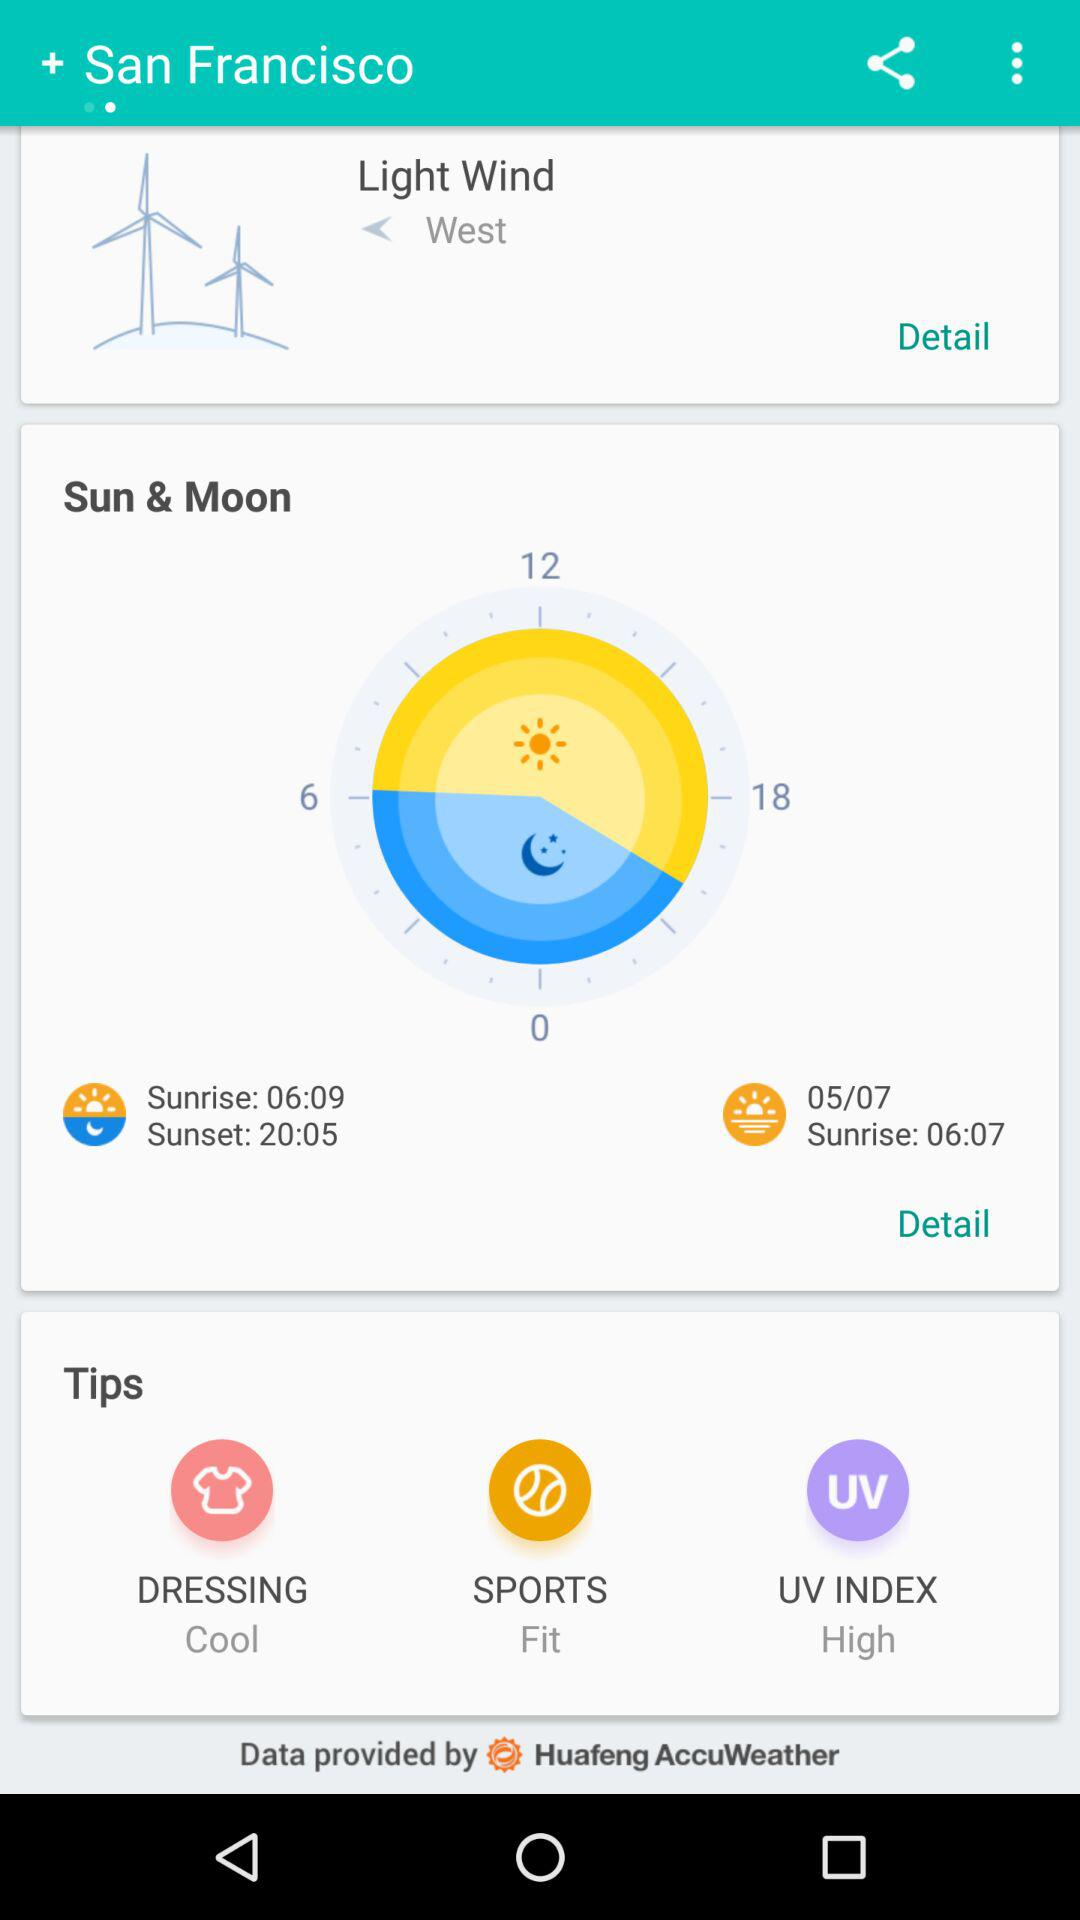How many days are included in the sunrise and sunset information?
Answer the question using a single word or phrase. 2 